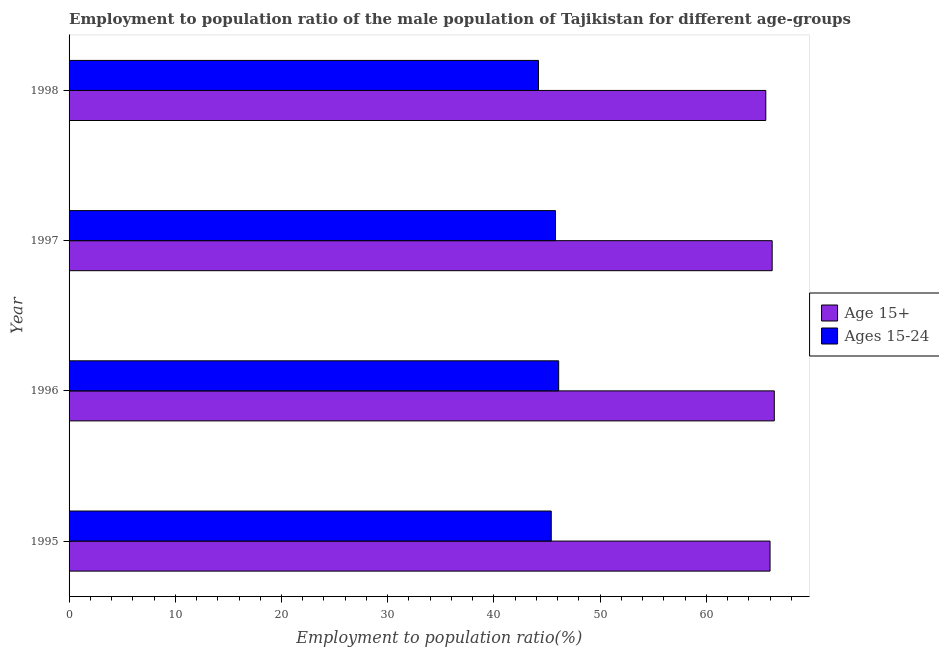How many different coloured bars are there?
Provide a succinct answer. 2. What is the employment to population ratio(age 15-24) in 1997?
Your answer should be compact. 45.8. Across all years, what is the maximum employment to population ratio(age 15-24)?
Your answer should be very brief. 46.1. Across all years, what is the minimum employment to population ratio(age 15+)?
Your answer should be compact. 65.6. In which year was the employment to population ratio(age 15+) minimum?
Offer a terse response. 1998. What is the total employment to population ratio(age 15-24) in the graph?
Provide a short and direct response. 181.5. What is the difference between the employment to population ratio(age 15-24) in 1997 and that in 1998?
Offer a terse response. 1.6. What is the difference between the employment to population ratio(age 15+) in 1996 and the employment to population ratio(age 15-24) in 1998?
Provide a succinct answer. 22.2. What is the average employment to population ratio(age 15-24) per year?
Give a very brief answer. 45.38. In the year 1996, what is the difference between the employment to population ratio(age 15+) and employment to population ratio(age 15-24)?
Offer a terse response. 20.3. Is the employment to population ratio(age 15-24) in 1995 less than that in 1997?
Give a very brief answer. Yes. Is the difference between the employment to population ratio(age 15-24) in 1995 and 1997 greater than the difference between the employment to population ratio(age 15+) in 1995 and 1997?
Give a very brief answer. No. What is the difference between the highest and the second highest employment to population ratio(age 15-24)?
Ensure brevity in your answer.  0.3. In how many years, is the employment to population ratio(age 15+) greater than the average employment to population ratio(age 15+) taken over all years?
Your answer should be very brief. 2. What does the 2nd bar from the top in 1997 represents?
Your answer should be very brief. Age 15+. What does the 1st bar from the bottom in 1996 represents?
Provide a succinct answer. Age 15+. How many bars are there?
Your answer should be compact. 8. Does the graph contain any zero values?
Your answer should be very brief. No. How many legend labels are there?
Provide a succinct answer. 2. How are the legend labels stacked?
Ensure brevity in your answer.  Vertical. What is the title of the graph?
Give a very brief answer. Employment to population ratio of the male population of Tajikistan for different age-groups. Does "Non-solid fuel" appear as one of the legend labels in the graph?
Ensure brevity in your answer.  No. What is the label or title of the Y-axis?
Make the answer very short. Year. What is the Employment to population ratio(%) in Ages 15-24 in 1995?
Make the answer very short. 45.4. What is the Employment to population ratio(%) in Age 15+ in 1996?
Your answer should be very brief. 66.4. What is the Employment to population ratio(%) in Ages 15-24 in 1996?
Offer a terse response. 46.1. What is the Employment to population ratio(%) of Age 15+ in 1997?
Offer a very short reply. 66.2. What is the Employment to population ratio(%) in Ages 15-24 in 1997?
Provide a succinct answer. 45.8. What is the Employment to population ratio(%) in Age 15+ in 1998?
Your answer should be compact. 65.6. What is the Employment to population ratio(%) in Ages 15-24 in 1998?
Your response must be concise. 44.2. Across all years, what is the maximum Employment to population ratio(%) of Age 15+?
Offer a terse response. 66.4. Across all years, what is the maximum Employment to population ratio(%) of Ages 15-24?
Provide a short and direct response. 46.1. Across all years, what is the minimum Employment to population ratio(%) of Age 15+?
Make the answer very short. 65.6. Across all years, what is the minimum Employment to population ratio(%) of Ages 15-24?
Your answer should be compact. 44.2. What is the total Employment to population ratio(%) of Age 15+ in the graph?
Offer a very short reply. 264.2. What is the total Employment to population ratio(%) in Ages 15-24 in the graph?
Ensure brevity in your answer.  181.5. What is the difference between the Employment to population ratio(%) of Age 15+ in 1995 and that in 1997?
Keep it short and to the point. -0.2. What is the difference between the Employment to population ratio(%) of Ages 15-24 in 1995 and that in 1997?
Give a very brief answer. -0.4. What is the difference between the Employment to population ratio(%) of Age 15+ in 1995 and that in 1998?
Give a very brief answer. 0.4. What is the difference between the Employment to population ratio(%) in Ages 15-24 in 1995 and that in 1998?
Your answer should be compact. 1.2. What is the difference between the Employment to population ratio(%) of Age 15+ in 1996 and that in 1997?
Provide a short and direct response. 0.2. What is the difference between the Employment to population ratio(%) in Ages 15-24 in 1996 and that in 1997?
Make the answer very short. 0.3. What is the difference between the Employment to population ratio(%) of Age 15+ in 1996 and that in 1998?
Your answer should be compact. 0.8. What is the difference between the Employment to population ratio(%) of Ages 15-24 in 1996 and that in 1998?
Ensure brevity in your answer.  1.9. What is the difference between the Employment to population ratio(%) of Age 15+ in 1997 and that in 1998?
Ensure brevity in your answer.  0.6. What is the difference between the Employment to population ratio(%) in Ages 15-24 in 1997 and that in 1998?
Keep it short and to the point. 1.6. What is the difference between the Employment to population ratio(%) in Age 15+ in 1995 and the Employment to population ratio(%) in Ages 15-24 in 1996?
Give a very brief answer. 19.9. What is the difference between the Employment to population ratio(%) of Age 15+ in 1995 and the Employment to population ratio(%) of Ages 15-24 in 1997?
Provide a succinct answer. 20.2. What is the difference between the Employment to population ratio(%) of Age 15+ in 1995 and the Employment to population ratio(%) of Ages 15-24 in 1998?
Keep it short and to the point. 21.8. What is the difference between the Employment to population ratio(%) of Age 15+ in 1996 and the Employment to population ratio(%) of Ages 15-24 in 1997?
Ensure brevity in your answer.  20.6. What is the difference between the Employment to population ratio(%) in Age 15+ in 1997 and the Employment to population ratio(%) in Ages 15-24 in 1998?
Provide a succinct answer. 22. What is the average Employment to population ratio(%) of Age 15+ per year?
Your answer should be very brief. 66.05. What is the average Employment to population ratio(%) of Ages 15-24 per year?
Your response must be concise. 45.38. In the year 1995, what is the difference between the Employment to population ratio(%) in Age 15+ and Employment to population ratio(%) in Ages 15-24?
Your answer should be compact. 20.6. In the year 1996, what is the difference between the Employment to population ratio(%) in Age 15+ and Employment to population ratio(%) in Ages 15-24?
Provide a short and direct response. 20.3. In the year 1997, what is the difference between the Employment to population ratio(%) of Age 15+ and Employment to population ratio(%) of Ages 15-24?
Your response must be concise. 20.4. In the year 1998, what is the difference between the Employment to population ratio(%) of Age 15+ and Employment to population ratio(%) of Ages 15-24?
Provide a short and direct response. 21.4. What is the ratio of the Employment to population ratio(%) of Age 15+ in 1995 to that in 1996?
Provide a succinct answer. 0.99. What is the ratio of the Employment to population ratio(%) in Ages 15-24 in 1995 to that in 1997?
Your response must be concise. 0.99. What is the ratio of the Employment to population ratio(%) of Age 15+ in 1995 to that in 1998?
Offer a terse response. 1.01. What is the ratio of the Employment to population ratio(%) in Ages 15-24 in 1995 to that in 1998?
Make the answer very short. 1.03. What is the ratio of the Employment to population ratio(%) of Age 15+ in 1996 to that in 1997?
Make the answer very short. 1. What is the ratio of the Employment to population ratio(%) of Ages 15-24 in 1996 to that in 1997?
Ensure brevity in your answer.  1.01. What is the ratio of the Employment to population ratio(%) in Age 15+ in 1996 to that in 1998?
Give a very brief answer. 1.01. What is the ratio of the Employment to population ratio(%) in Ages 15-24 in 1996 to that in 1998?
Your answer should be very brief. 1.04. What is the ratio of the Employment to population ratio(%) in Age 15+ in 1997 to that in 1998?
Your answer should be very brief. 1.01. What is the ratio of the Employment to population ratio(%) in Ages 15-24 in 1997 to that in 1998?
Make the answer very short. 1.04. 